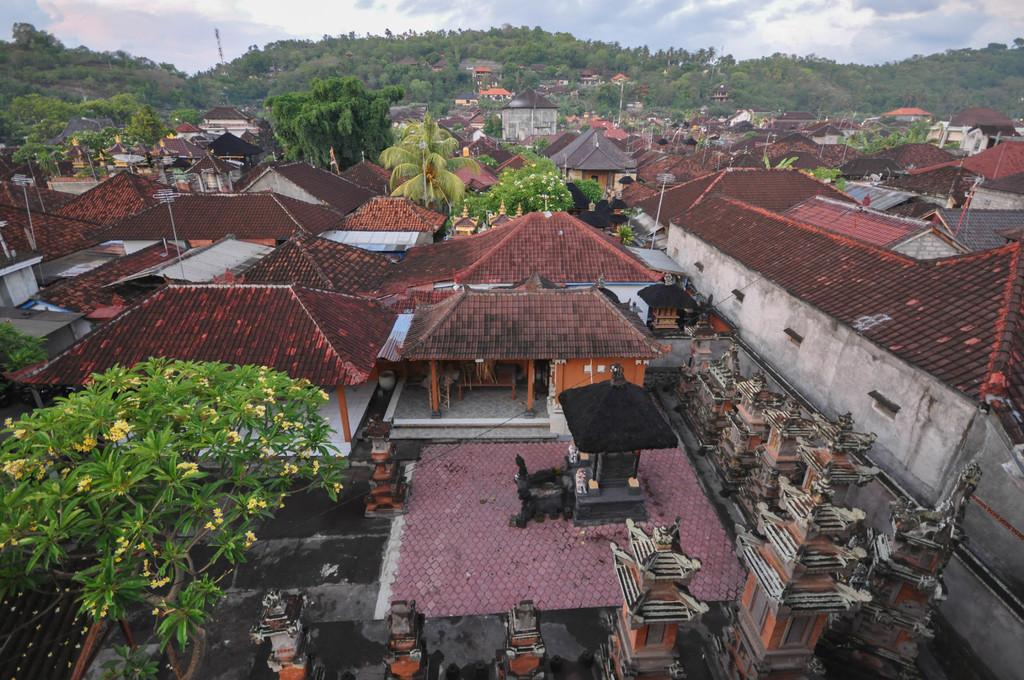What can be seen in the foreground of the image? There are houses, trees, and poles in the foreground of the image. What type of vegetation is present in the foreground? Trees are present in the foreground of the image. What is visible in the background of the image? There is greenery and sky visible in the background of the image. How many brothers are depicted in the image? There are no brothers present in the image; it features houses, trees, poles, greenery, and sky. What type of hall can be seen in the image? There is no hall present in the image. 